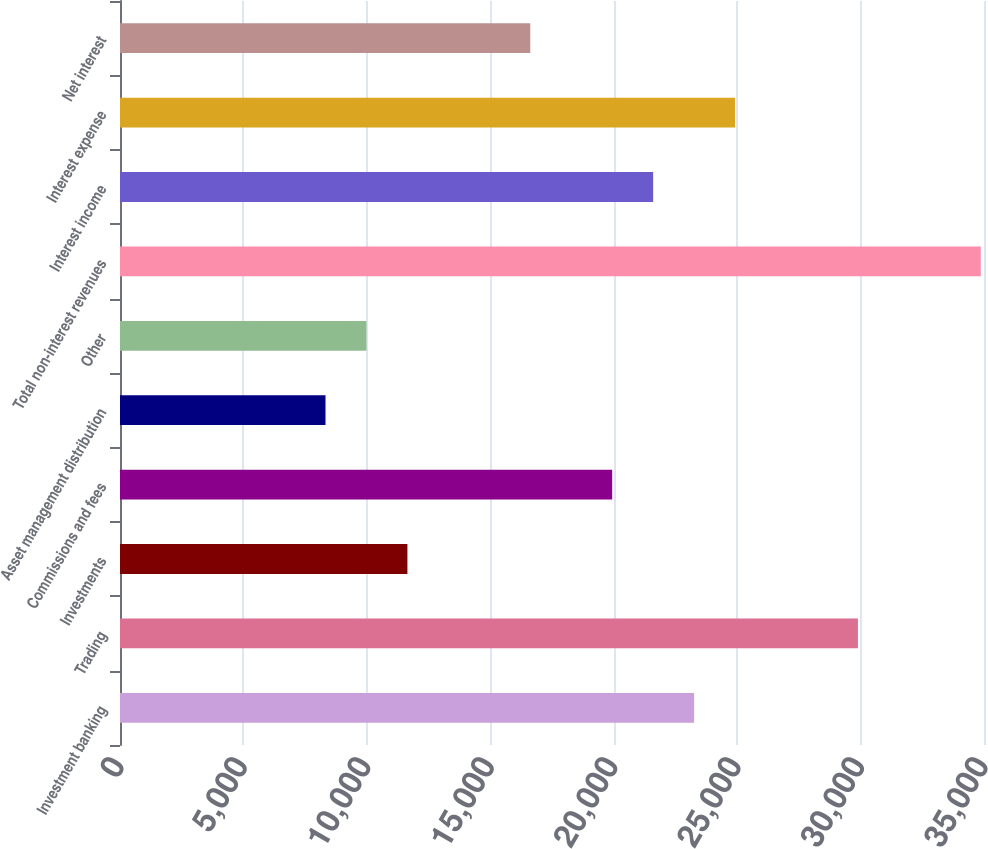Convert chart. <chart><loc_0><loc_0><loc_500><loc_500><bar_chart><fcel>Investment banking<fcel>Trading<fcel>Investments<fcel>Commissions and fees<fcel>Asset management distribution<fcel>Other<fcel>Total non-interest revenues<fcel>Interest income<fcel>Interest expense<fcel>Net interest<nl><fcel>23256.4<fcel>29892.8<fcel>11642.7<fcel>19938.2<fcel>8324.5<fcel>9983.6<fcel>34870.1<fcel>21597.3<fcel>24915.5<fcel>16620<nl></chart> 